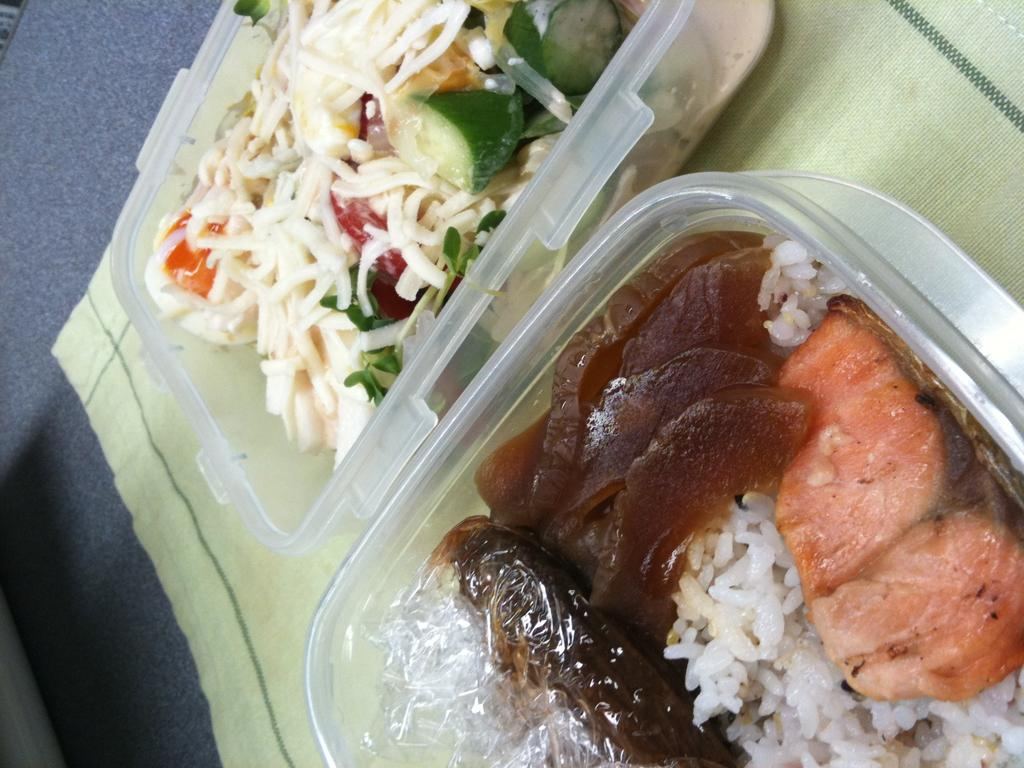How many boxes can be seen in the image? There are two boxes in the image. Where are the boxes located? The boxes are kept on the floor. What is inside the boxes? There is food visible in the boxes. What type of list can be seen inside the drawer in the image? There is no drawer present in the image, and therefore no list can be seen inside it. 